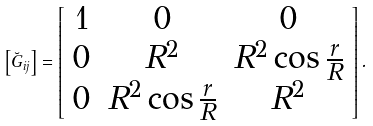Convert formula to latex. <formula><loc_0><loc_0><loc_500><loc_500>\left [ \breve { G } _ { i j } \right ] = \left [ \begin{array} { c c c } 1 & 0 & 0 \\ 0 & R ^ { 2 } & R ^ { 2 } \cos \frac { r } { R } \\ 0 & R ^ { 2 } \cos \frac { r } { R } & R ^ { 2 } \end{array} \right ] .</formula> 